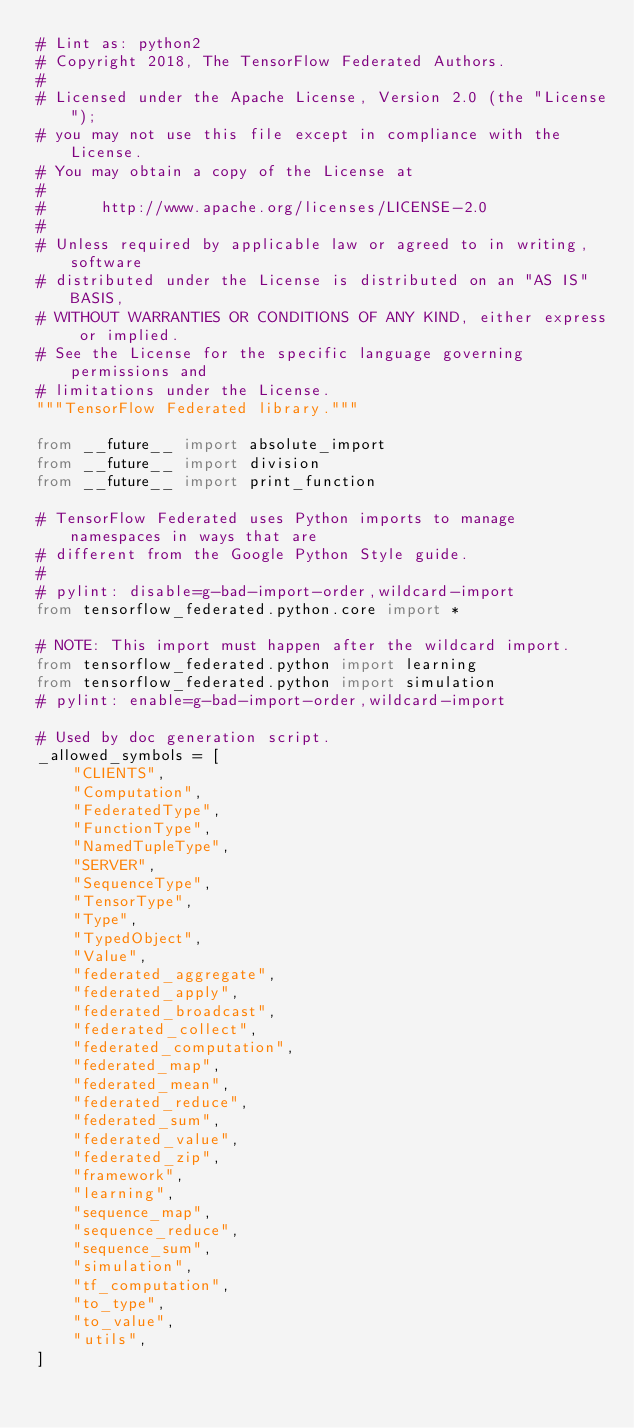<code> <loc_0><loc_0><loc_500><loc_500><_Python_># Lint as: python2
# Copyright 2018, The TensorFlow Federated Authors.
#
# Licensed under the Apache License, Version 2.0 (the "License");
# you may not use this file except in compliance with the License.
# You may obtain a copy of the License at
#
#      http://www.apache.org/licenses/LICENSE-2.0
#
# Unless required by applicable law or agreed to in writing, software
# distributed under the License is distributed on an "AS IS" BASIS,
# WITHOUT WARRANTIES OR CONDITIONS OF ANY KIND, either express or implied.
# See the License for the specific language governing permissions and
# limitations under the License.
"""TensorFlow Federated library."""

from __future__ import absolute_import
from __future__ import division
from __future__ import print_function

# TensorFlow Federated uses Python imports to manage namespaces in ways that are
# different from the Google Python Style guide.
#
# pylint: disable=g-bad-import-order,wildcard-import
from tensorflow_federated.python.core import *

# NOTE: This import must happen after the wildcard import.
from tensorflow_federated.python import learning
from tensorflow_federated.python import simulation
# pylint: enable=g-bad-import-order,wildcard-import

# Used by doc generation script.
_allowed_symbols = [
    "CLIENTS",
    "Computation",
    "FederatedType",
    "FunctionType",
    "NamedTupleType",
    "SERVER",
    "SequenceType",
    "TensorType",
    "Type",
    "TypedObject",
    "Value",
    "federated_aggregate",
    "federated_apply",
    "federated_broadcast",
    "federated_collect",
    "federated_computation",
    "federated_map",
    "federated_mean",
    "federated_reduce",
    "federated_sum",
    "federated_value",
    "federated_zip",
    "framework",
    "learning",
    "sequence_map",
    "sequence_reduce",
    "sequence_sum",
    "simulation",
    "tf_computation",
    "to_type",
    "to_value",
    "utils",
]
</code> 